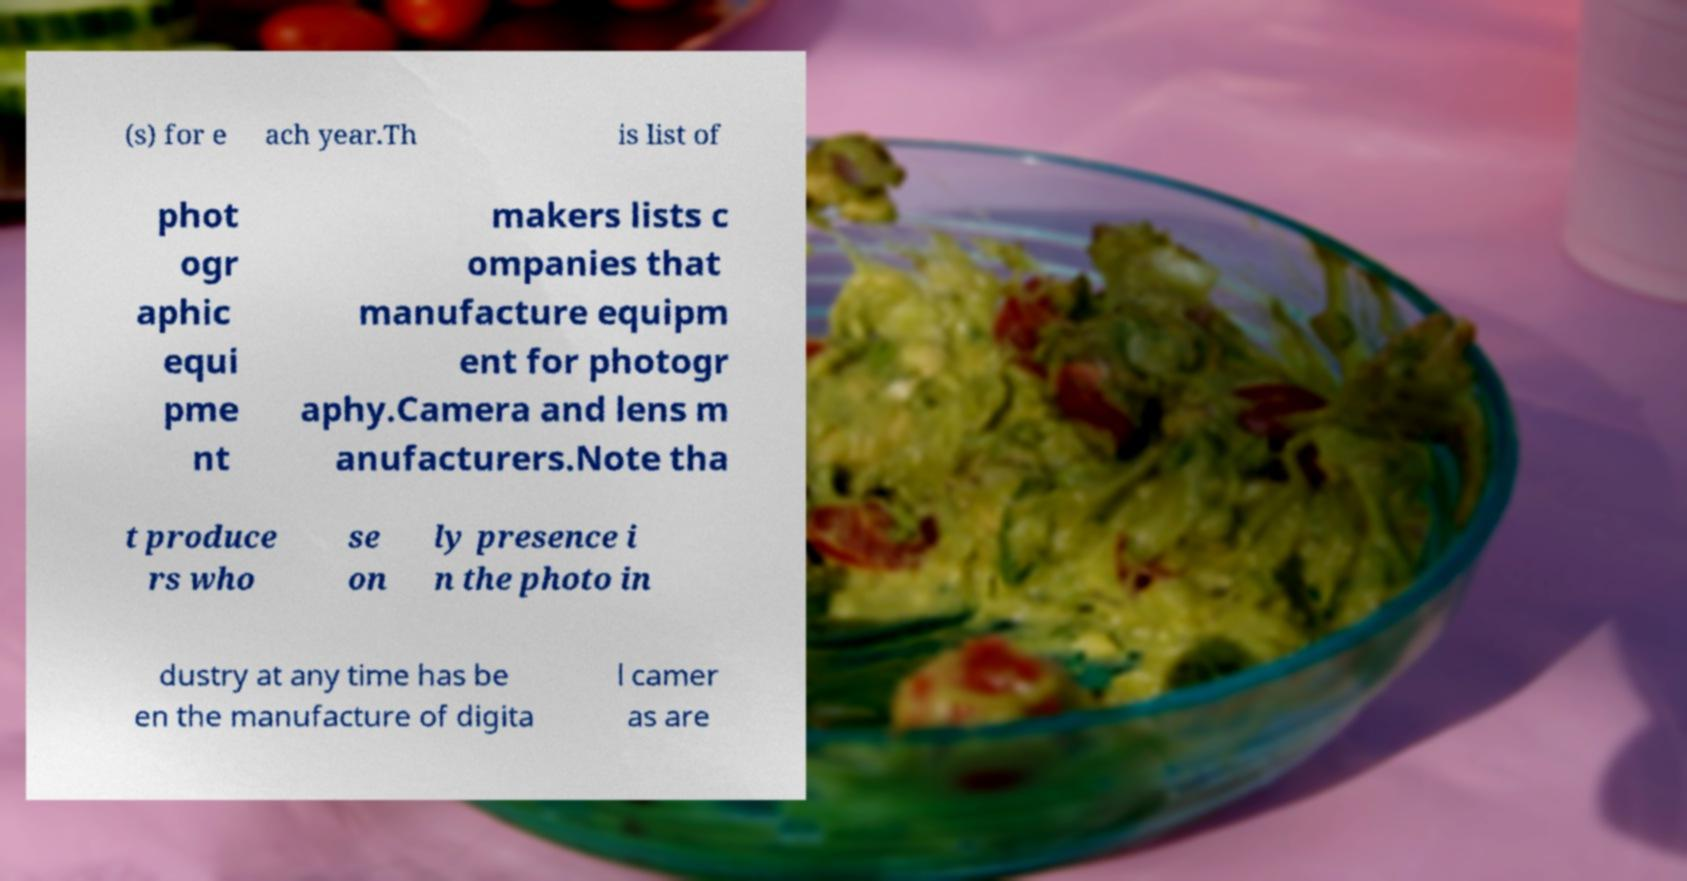For documentation purposes, I need the text within this image transcribed. Could you provide that? (s) for e ach year.Th is list of phot ogr aphic equi pme nt makers lists c ompanies that manufacture equipm ent for photogr aphy.Camera and lens m anufacturers.Note tha t produce rs who se on ly presence i n the photo in dustry at any time has be en the manufacture of digita l camer as are 